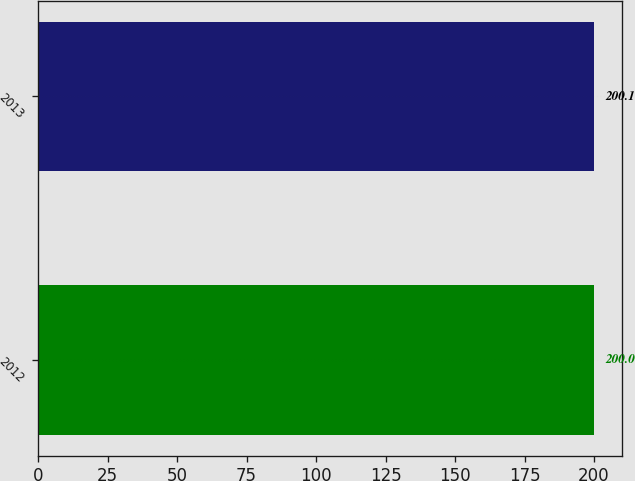Convert chart. <chart><loc_0><loc_0><loc_500><loc_500><bar_chart><fcel>2012<fcel>2013<nl><fcel>200<fcel>200.1<nl></chart> 